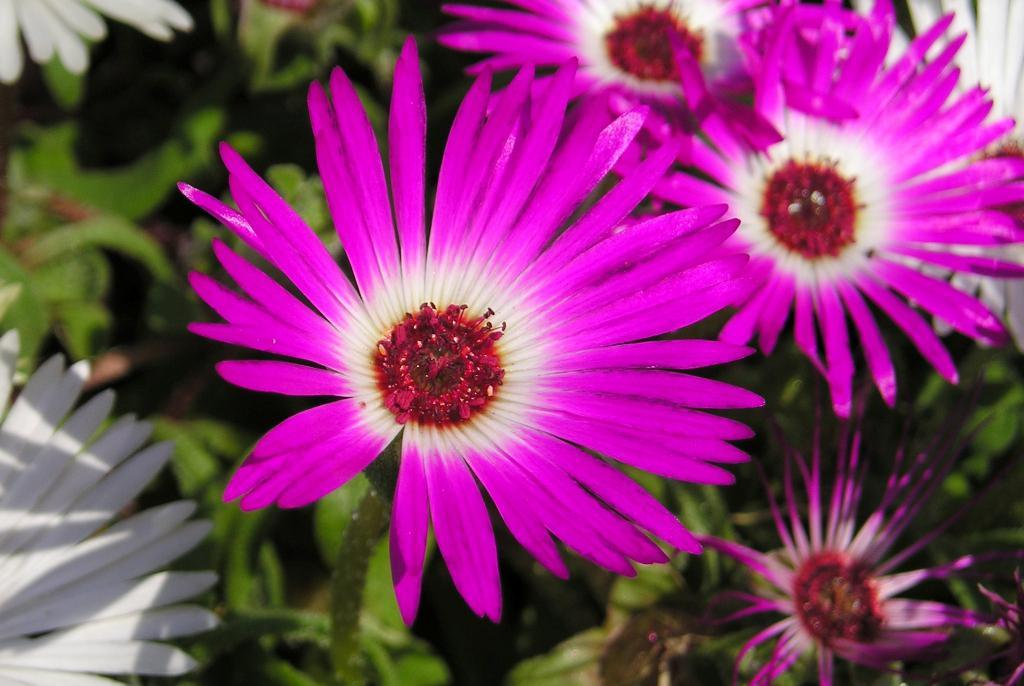What celestial bodies are depicted in the image? There are planets in the image. What distinguishes the planets from one another? The planets have different colored flowers. Can you see a bee buzzing around the flowers on the planets in the image? There is no bee present in the image; the image only depicts planets with different colored flowers. 